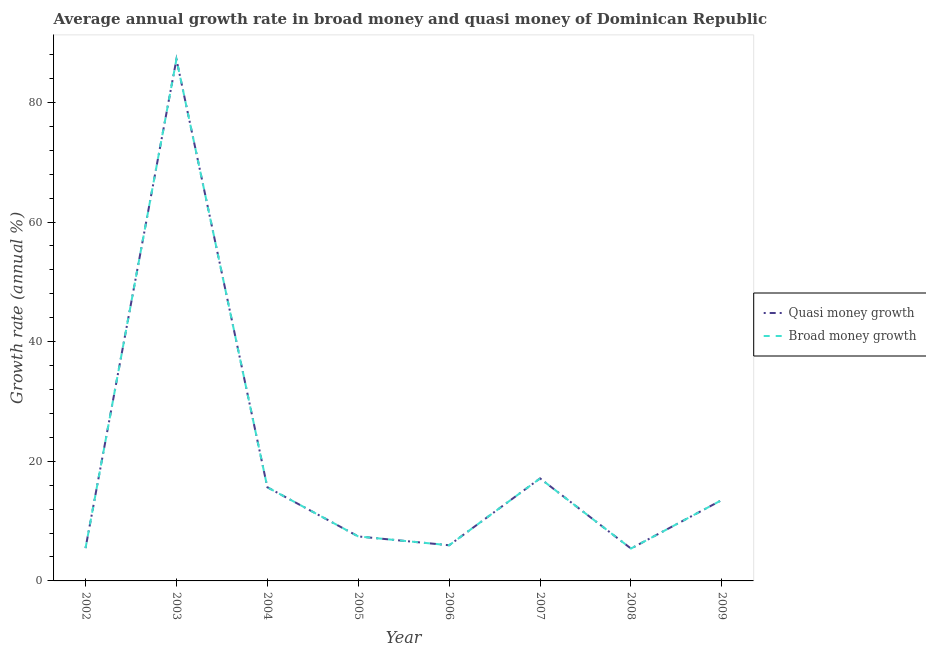How many different coloured lines are there?
Offer a very short reply. 2. Does the line corresponding to annual growth rate in broad money intersect with the line corresponding to annual growth rate in quasi money?
Give a very brief answer. Yes. Is the number of lines equal to the number of legend labels?
Provide a succinct answer. Yes. What is the annual growth rate in quasi money in 2009?
Your answer should be compact. 13.53. Across all years, what is the maximum annual growth rate in broad money?
Your response must be concise. 87.2. Across all years, what is the minimum annual growth rate in broad money?
Ensure brevity in your answer.  5.41. In which year was the annual growth rate in quasi money minimum?
Your answer should be compact. 2008. What is the total annual growth rate in quasi money in the graph?
Provide a succinct answer. 157.82. What is the difference between the annual growth rate in broad money in 2004 and that in 2009?
Offer a very short reply. 2.13. What is the difference between the annual growth rate in quasi money in 2004 and the annual growth rate in broad money in 2005?
Your answer should be compact. 8.22. What is the average annual growth rate in broad money per year?
Your answer should be very brief. 19.73. In the year 2008, what is the difference between the annual growth rate in quasi money and annual growth rate in broad money?
Provide a short and direct response. 0. What is the ratio of the annual growth rate in quasi money in 2003 to that in 2007?
Your answer should be compact. 5.09. Is the annual growth rate in quasi money in 2005 less than that in 2008?
Give a very brief answer. No. Is the difference between the annual growth rate in broad money in 2007 and 2008 greater than the difference between the annual growth rate in quasi money in 2007 and 2008?
Offer a very short reply. No. What is the difference between the highest and the second highest annual growth rate in broad money?
Your response must be concise. 70.06. What is the difference between the highest and the lowest annual growth rate in quasi money?
Keep it short and to the point. 81.79. In how many years, is the annual growth rate in quasi money greater than the average annual growth rate in quasi money taken over all years?
Offer a very short reply. 1. Does the annual growth rate in quasi money monotonically increase over the years?
Offer a terse response. No. How many lines are there?
Offer a very short reply. 2. What is the difference between two consecutive major ticks on the Y-axis?
Offer a very short reply. 20. Does the graph contain any zero values?
Provide a succinct answer. No. Does the graph contain grids?
Your response must be concise. No. Where does the legend appear in the graph?
Your answer should be compact. Center right. How many legend labels are there?
Give a very brief answer. 2. How are the legend labels stacked?
Your answer should be very brief. Vertical. What is the title of the graph?
Give a very brief answer. Average annual growth rate in broad money and quasi money of Dominican Republic. Does "Depositors" appear as one of the legend labels in the graph?
Your response must be concise. No. What is the label or title of the X-axis?
Make the answer very short. Year. What is the label or title of the Y-axis?
Your answer should be very brief. Growth rate (annual %). What is the Growth rate (annual %) in Quasi money growth in 2002?
Keep it short and to the point. 5.48. What is the Growth rate (annual %) of Broad money growth in 2002?
Offer a terse response. 5.48. What is the Growth rate (annual %) in Quasi money growth in 2003?
Your answer should be compact. 87.2. What is the Growth rate (annual %) in Broad money growth in 2003?
Provide a succinct answer. 87.2. What is the Growth rate (annual %) in Quasi money growth in 2004?
Offer a very short reply. 15.66. What is the Growth rate (annual %) of Broad money growth in 2004?
Your answer should be compact. 15.66. What is the Growth rate (annual %) in Quasi money growth in 2005?
Keep it short and to the point. 7.44. What is the Growth rate (annual %) of Broad money growth in 2005?
Your answer should be very brief. 7.44. What is the Growth rate (annual %) of Quasi money growth in 2006?
Provide a succinct answer. 5.96. What is the Growth rate (annual %) in Broad money growth in 2006?
Provide a short and direct response. 5.96. What is the Growth rate (annual %) in Quasi money growth in 2007?
Your answer should be very brief. 17.14. What is the Growth rate (annual %) of Broad money growth in 2007?
Your answer should be compact. 17.14. What is the Growth rate (annual %) of Quasi money growth in 2008?
Your answer should be very brief. 5.41. What is the Growth rate (annual %) in Broad money growth in 2008?
Keep it short and to the point. 5.41. What is the Growth rate (annual %) in Quasi money growth in 2009?
Provide a succinct answer. 13.53. What is the Growth rate (annual %) of Broad money growth in 2009?
Your answer should be compact. 13.53. Across all years, what is the maximum Growth rate (annual %) in Quasi money growth?
Make the answer very short. 87.2. Across all years, what is the maximum Growth rate (annual %) of Broad money growth?
Provide a succinct answer. 87.2. Across all years, what is the minimum Growth rate (annual %) of Quasi money growth?
Make the answer very short. 5.41. Across all years, what is the minimum Growth rate (annual %) of Broad money growth?
Keep it short and to the point. 5.41. What is the total Growth rate (annual %) in Quasi money growth in the graph?
Offer a very short reply. 157.82. What is the total Growth rate (annual %) of Broad money growth in the graph?
Keep it short and to the point. 157.82. What is the difference between the Growth rate (annual %) of Quasi money growth in 2002 and that in 2003?
Make the answer very short. -81.71. What is the difference between the Growth rate (annual %) of Broad money growth in 2002 and that in 2003?
Provide a succinct answer. -81.71. What is the difference between the Growth rate (annual %) of Quasi money growth in 2002 and that in 2004?
Make the answer very short. -10.17. What is the difference between the Growth rate (annual %) in Broad money growth in 2002 and that in 2004?
Ensure brevity in your answer.  -10.17. What is the difference between the Growth rate (annual %) in Quasi money growth in 2002 and that in 2005?
Give a very brief answer. -1.95. What is the difference between the Growth rate (annual %) in Broad money growth in 2002 and that in 2005?
Offer a terse response. -1.95. What is the difference between the Growth rate (annual %) in Quasi money growth in 2002 and that in 2006?
Keep it short and to the point. -0.48. What is the difference between the Growth rate (annual %) of Broad money growth in 2002 and that in 2006?
Offer a terse response. -0.48. What is the difference between the Growth rate (annual %) of Quasi money growth in 2002 and that in 2007?
Ensure brevity in your answer.  -11.65. What is the difference between the Growth rate (annual %) in Broad money growth in 2002 and that in 2007?
Keep it short and to the point. -11.65. What is the difference between the Growth rate (annual %) in Quasi money growth in 2002 and that in 2008?
Offer a very short reply. 0.07. What is the difference between the Growth rate (annual %) of Broad money growth in 2002 and that in 2008?
Give a very brief answer. 0.07. What is the difference between the Growth rate (annual %) of Quasi money growth in 2002 and that in 2009?
Provide a short and direct response. -8.05. What is the difference between the Growth rate (annual %) of Broad money growth in 2002 and that in 2009?
Make the answer very short. -8.05. What is the difference between the Growth rate (annual %) in Quasi money growth in 2003 and that in 2004?
Give a very brief answer. 71.54. What is the difference between the Growth rate (annual %) in Broad money growth in 2003 and that in 2004?
Give a very brief answer. 71.54. What is the difference between the Growth rate (annual %) of Quasi money growth in 2003 and that in 2005?
Offer a terse response. 79.76. What is the difference between the Growth rate (annual %) of Broad money growth in 2003 and that in 2005?
Make the answer very short. 79.76. What is the difference between the Growth rate (annual %) in Quasi money growth in 2003 and that in 2006?
Make the answer very short. 81.24. What is the difference between the Growth rate (annual %) of Broad money growth in 2003 and that in 2006?
Offer a very short reply. 81.24. What is the difference between the Growth rate (annual %) of Quasi money growth in 2003 and that in 2007?
Your response must be concise. 70.06. What is the difference between the Growth rate (annual %) of Broad money growth in 2003 and that in 2007?
Make the answer very short. 70.06. What is the difference between the Growth rate (annual %) in Quasi money growth in 2003 and that in 2008?
Offer a terse response. 81.79. What is the difference between the Growth rate (annual %) of Broad money growth in 2003 and that in 2008?
Give a very brief answer. 81.79. What is the difference between the Growth rate (annual %) in Quasi money growth in 2003 and that in 2009?
Your answer should be compact. 73.67. What is the difference between the Growth rate (annual %) in Broad money growth in 2003 and that in 2009?
Offer a terse response. 73.67. What is the difference between the Growth rate (annual %) in Quasi money growth in 2004 and that in 2005?
Your answer should be compact. 8.22. What is the difference between the Growth rate (annual %) of Broad money growth in 2004 and that in 2005?
Provide a short and direct response. 8.22. What is the difference between the Growth rate (annual %) of Quasi money growth in 2004 and that in 2006?
Your response must be concise. 9.69. What is the difference between the Growth rate (annual %) in Broad money growth in 2004 and that in 2006?
Provide a succinct answer. 9.69. What is the difference between the Growth rate (annual %) of Quasi money growth in 2004 and that in 2007?
Offer a very short reply. -1.48. What is the difference between the Growth rate (annual %) in Broad money growth in 2004 and that in 2007?
Keep it short and to the point. -1.48. What is the difference between the Growth rate (annual %) in Quasi money growth in 2004 and that in 2008?
Offer a terse response. 10.24. What is the difference between the Growth rate (annual %) in Broad money growth in 2004 and that in 2008?
Make the answer very short. 10.24. What is the difference between the Growth rate (annual %) in Quasi money growth in 2004 and that in 2009?
Keep it short and to the point. 2.12. What is the difference between the Growth rate (annual %) in Broad money growth in 2004 and that in 2009?
Provide a short and direct response. 2.12. What is the difference between the Growth rate (annual %) in Quasi money growth in 2005 and that in 2006?
Keep it short and to the point. 1.48. What is the difference between the Growth rate (annual %) of Broad money growth in 2005 and that in 2006?
Your answer should be compact. 1.48. What is the difference between the Growth rate (annual %) in Quasi money growth in 2005 and that in 2007?
Give a very brief answer. -9.7. What is the difference between the Growth rate (annual %) of Broad money growth in 2005 and that in 2007?
Provide a succinct answer. -9.7. What is the difference between the Growth rate (annual %) of Quasi money growth in 2005 and that in 2008?
Your answer should be very brief. 2.03. What is the difference between the Growth rate (annual %) of Broad money growth in 2005 and that in 2008?
Provide a succinct answer. 2.03. What is the difference between the Growth rate (annual %) of Quasi money growth in 2005 and that in 2009?
Keep it short and to the point. -6.09. What is the difference between the Growth rate (annual %) in Broad money growth in 2005 and that in 2009?
Your response must be concise. -6.09. What is the difference between the Growth rate (annual %) in Quasi money growth in 2006 and that in 2007?
Ensure brevity in your answer.  -11.17. What is the difference between the Growth rate (annual %) in Broad money growth in 2006 and that in 2007?
Your response must be concise. -11.17. What is the difference between the Growth rate (annual %) in Quasi money growth in 2006 and that in 2008?
Give a very brief answer. 0.55. What is the difference between the Growth rate (annual %) of Broad money growth in 2006 and that in 2008?
Your answer should be compact. 0.55. What is the difference between the Growth rate (annual %) in Quasi money growth in 2006 and that in 2009?
Provide a succinct answer. -7.57. What is the difference between the Growth rate (annual %) of Broad money growth in 2006 and that in 2009?
Provide a short and direct response. -7.57. What is the difference between the Growth rate (annual %) of Quasi money growth in 2007 and that in 2008?
Offer a terse response. 11.72. What is the difference between the Growth rate (annual %) of Broad money growth in 2007 and that in 2008?
Offer a very short reply. 11.72. What is the difference between the Growth rate (annual %) of Quasi money growth in 2007 and that in 2009?
Offer a very short reply. 3.61. What is the difference between the Growth rate (annual %) of Broad money growth in 2007 and that in 2009?
Your answer should be very brief. 3.61. What is the difference between the Growth rate (annual %) of Quasi money growth in 2008 and that in 2009?
Ensure brevity in your answer.  -8.12. What is the difference between the Growth rate (annual %) of Broad money growth in 2008 and that in 2009?
Offer a terse response. -8.12. What is the difference between the Growth rate (annual %) in Quasi money growth in 2002 and the Growth rate (annual %) in Broad money growth in 2003?
Give a very brief answer. -81.71. What is the difference between the Growth rate (annual %) in Quasi money growth in 2002 and the Growth rate (annual %) in Broad money growth in 2004?
Provide a short and direct response. -10.17. What is the difference between the Growth rate (annual %) in Quasi money growth in 2002 and the Growth rate (annual %) in Broad money growth in 2005?
Provide a short and direct response. -1.95. What is the difference between the Growth rate (annual %) of Quasi money growth in 2002 and the Growth rate (annual %) of Broad money growth in 2006?
Provide a short and direct response. -0.48. What is the difference between the Growth rate (annual %) in Quasi money growth in 2002 and the Growth rate (annual %) in Broad money growth in 2007?
Keep it short and to the point. -11.65. What is the difference between the Growth rate (annual %) of Quasi money growth in 2002 and the Growth rate (annual %) of Broad money growth in 2008?
Your answer should be very brief. 0.07. What is the difference between the Growth rate (annual %) of Quasi money growth in 2002 and the Growth rate (annual %) of Broad money growth in 2009?
Keep it short and to the point. -8.05. What is the difference between the Growth rate (annual %) in Quasi money growth in 2003 and the Growth rate (annual %) in Broad money growth in 2004?
Offer a terse response. 71.54. What is the difference between the Growth rate (annual %) of Quasi money growth in 2003 and the Growth rate (annual %) of Broad money growth in 2005?
Provide a short and direct response. 79.76. What is the difference between the Growth rate (annual %) in Quasi money growth in 2003 and the Growth rate (annual %) in Broad money growth in 2006?
Offer a terse response. 81.24. What is the difference between the Growth rate (annual %) of Quasi money growth in 2003 and the Growth rate (annual %) of Broad money growth in 2007?
Your response must be concise. 70.06. What is the difference between the Growth rate (annual %) in Quasi money growth in 2003 and the Growth rate (annual %) in Broad money growth in 2008?
Ensure brevity in your answer.  81.79. What is the difference between the Growth rate (annual %) in Quasi money growth in 2003 and the Growth rate (annual %) in Broad money growth in 2009?
Give a very brief answer. 73.67. What is the difference between the Growth rate (annual %) in Quasi money growth in 2004 and the Growth rate (annual %) in Broad money growth in 2005?
Give a very brief answer. 8.22. What is the difference between the Growth rate (annual %) in Quasi money growth in 2004 and the Growth rate (annual %) in Broad money growth in 2006?
Offer a very short reply. 9.69. What is the difference between the Growth rate (annual %) of Quasi money growth in 2004 and the Growth rate (annual %) of Broad money growth in 2007?
Ensure brevity in your answer.  -1.48. What is the difference between the Growth rate (annual %) in Quasi money growth in 2004 and the Growth rate (annual %) in Broad money growth in 2008?
Your answer should be compact. 10.24. What is the difference between the Growth rate (annual %) of Quasi money growth in 2004 and the Growth rate (annual %) of Broad money growth in 2009?
Your answer should be compact. 2.12. What is the difference between the Growth rate (annual %) of Quasi money growth in 2005 and the Growth rate (annual %) of Broad money growth in 2006?
Make the answer very short. 1.48. What is the difference between the Growth rate (annual %) of Quasi money growth in 2005 and the Growth rate (annual %) of Broad money growth in 2007?
Give a very brief answer. -9.7. What is the difference between the Growth rate (annual %) of Quasi money growth in 2005 and the Growth rate (annual %) of Broad money growth in 2008?
Offer a very short reply. 2.03. What is the difference between the Growth rate (annual %) in Quasi money growth in 2005 and the Growth rate (annual %) in Broad money growth in 2009?
Your answer should be compact. -6.09. What is the difference between the Growth rate (annual %) of Quasi money growth in 2006 and the Growth rate (annual %) of Broad money growth in 2007?
Make the answer very short. -11.17. What is the difference between the Growth rate (annual %) in Quasi money growth in 2006 and the Growth rate (annual %) in Broad money growth in 2008?
Give a very brief answer. 0.55. What is the difference between the Growth rate (annual %) in Quasi money growth in 2006 and the Growth rate (annual %) in Broad money growth in 2009?
Your answer should be very brief. -7.57. What is the difference between the Growth rate (annual %) of Quasi money growth in 2007 and the Growth rate (annual %) of Broad money growth in 2008?
Your response must be concise. 11.72. What is the difference between the Growth rate (annual %) in Quasi money growth in 2007 and the Growth rate (annual %) in Broad money growth in 2009?
Your answer should be very brief. 3.61. What is the difference between the Growth rate (annual %) of Quasi money growth in 2008 and the Growth rate (annual %) of Broad money growth in 2009?
Offer a very short reply. -8.12. What is the average Growth rate (annual %) in Quasi money growth per year?
Make the answer very short. 19.73. What is the average Growth rate (annual %) in Broad money growth per year?
Ensure brevity in your answer.  19.73. In the year 2002, what is the difference between the Growth rate (annual %) in Quasi money growth and Growth rate (annual %) in Broad money growth?
Ensure brevity in your answer.  0. In the year 2003, what is the difference between the Growth rate (annual %) in Quasi money growth and Growth rate (annual %) in Broad money growth?
Keep it short and to the point. 0. In the year 2005, what is the difference between the Growth rate (annual %) of Quasi money growth and Growth rate (annual %) of Broad money growth?
Keep it short and to the point. 0. In the year 2006, what is the difference between the Growth rate (annual %) of Quasi money growth and Growth rate (annual %) of Broad money growth?
Your answer should be very brief. 0. In the year 2007, what is the difference between the Growth rate (annual %) of Quasi money growth and Growth rate (annual %) of Broad money growth?
Offer a terse response. 0. In the year 2009, what is the difference between the Growth rate (annual %) in Quasi money growth and Growth rate (annual %) in Broad money growth?
Your answer should be very brief. 0. What is the ratio of the Growth rate (annual %) of Quasi money growth in 2002 to that in 2003?
Your response must be concise. 0.06. What is the ratio of the Growth rate (annual %) of Broad money growth in 2002 to that in 2003?
Your answer should be very brief. 0.06. What is the ratio of the Growth rate (annual %) in Quasi money growth in 2002 to that in 2004?
Keep it short and to the point. 0.35. What is the ratio of the Growth rate (annual %) in Broad money growth in 2002 to that in 2004?
Give a very brief answer. 0.35. What is the ratio of the Growth rate (annual %) in Quasi money growth in 2002 to that in 2005?
Your answer should be compact. 0.74. What is the ratio of the Growth rate (annual %) of Broad money growth in 2002 to that in 2005?
Make the answer very short. 0.74. What is the ratio of the Growth rate (annual %) of Quasi money growth in 2002 to that in 2006?
Offer a very short reply. 0.92. What is the ratio of the Growth rate (annual %) of Broad money growth in 2002 to that in 2006?
Your answer should be very brief. 0.92. What is the ratio of the Growth rate (annual %) of Quasi money growth in 2002 to that in 2007?
Offer a very short reply. 0.32. What is the ratio of the Growth rate (annual %) of Broad money growth in 2002 to that in 2007?
Provide a succinct answer. 0.32. What is the ratio of the Growth rate (annual %) of Quasi money growth in 2002 to that in 2008?
Offer a terse response. 1.01. What is the ratio of the Growth rate (annual %) in Broad money growth in 2002 to that in 2008?
Your answer should be compact. 1.01. What is the ratio of the Growth rate (annual %) in Quasi money growth in 2002 to that in 2009?
Your response must be concise. 0.41. What is the ratio of the Growth rate (annual %) in Broad money growth in 2002 to that in 2009?
Offer a terse response. 0.41. What is the ratio of the Growth rate (annual %) in Quasi money growth in 2003 to that in 2004?
Your response must be concise. 5.57. What is the ratio of the Growth rate (annual %) of Broad money growth in 2003 to that in 2004?
Give a very brief answer. 5.57. What is the ratio of the Growth rate (annual %) of Quasi money growth in 2003 to that in 2005?
Offer a terse response. 11.72. What is the ratio of the Growth rate (annual %) in Broad money growth in 2003 to that in 2005?
Ensure brevity in your answer.  11.72. What is the ratio of the Growth rate (annual %) of Quasi money growth in 2003 to that in 2006?
Make the answer very short. 14.62. What is the ratio of the Growth rate (annual %) in Broad money growth in 2003 to that in 2006?
Give a very brief answer. 14.62. What is the ratio of the Growth rate (annual %) in Quasi money growth in 2003 to that in 2007?
Make the answer very short. 5.09. What is the ratio of the Growth rate (annual %) of Broad money growth in 2003 to that in 2007?
Make the answer very short. 5.09. What is the ratio of the Growth rate (annual %) in Quasi money growth in 2003 to that in 2008?
Your answer should be very brief. 16.11. What is the ratio of the Growth rate (annual %) of Broad money growth in 2003 to that in 2008?
Your answer should be compact. 16.11. What is the ratio of the Growth rate (annual %) in Quasi money growth in 2003 to that in 2009?
Offer a very short reply. 6.44. What is the ratio of the Growth rate (annual %) of Broad money growth in 2003 to that in 2009?
Provide a succinct answer. 6.44. What is the ratio of the Growth rate (annual %) in Quasi money growth in 2004 to that in 2005?
Keep it short and to the point. 2.11. What is the ratio of the Growth rate (annual %) in Broad money growth in 2004 to that in 2005?
Your answer should be very brief. 2.11. What is the ratio of the Growth rate (annual %) in Quasi money growth in 2004 to that in 2006?
Give a very brief answer. 2.63. What is the ratio of the Growth rate (annual %) in Broad money growth in 2004 to that in 2006?
Provide a succinct answer. 2.63. What is the ratio of the Growth rate (annual %) in Quasi money growth in 2004 to that in 2007?
Provide a succinct answer. 0.91. What is the ratio of the Growth rate (annual %) of Broad money growth in 2004 to that in 2007?
Offer a very short reply. 0.91. What is the ratio of the Growth rate (annual %) in Quasi money growth in 2004 to that in 2008?
Keep it short and to the point. 2.89. What is the ratio of the Growth rate (annual %) in Broad money growth in 2004 to that in 2008?
Make the answer very short. 2.89. What is the ratio of the Growth rate (annual %) in Quasi money growth in 2004 to that in 2009?
Your answer should be very brief. 1.16. What is the ratio of the Growth rate (annual %) of Broad money growth in 2004 to that in 2009?
Provide a succinct answer. 1.16. What is the ratio of the Growth rate (annual %) in Quasi money growth in 2005 to that in 2006?
Offer a very short reply. 1.25. What is the ratio of the Growth rate (annual %) in Broad money growth in 2005 to that in 2006?
Ensure brevity in your answer.  1.25. What is the ratio of the Growth rate (annual %) in Quasi money growth in 2005 to that in 2007?
Make the answer very short. 0.43. What is the ratio of the Growth rate (annual %) of Broad money growth in 2005 to that in 2007?
Provide a succinct answer. 0.43. What is the ratio of the Growth rate (annual %) of Quasi money growth in 2005 to that in 2008?
Ensure brevity in your answer.  1.37. What is the ratio of the Growth rate (annual %) of Broad money growth in 2005 to that in 2008?
Give a very brief answer. 1.37. What is the ratio of the Growth rate (annual %) in Quasi money growth in 2005 to that in 2009?
Keep it short and to the point. 0.55. What is the ratio of the Growth rate (annual %) of Broad money growth in 2005 to that in 2009?
Ensure brevity in your answer.  0.55. What is the ratio of the Growth rate (annual %) in Quasi money growth in 2006 to that in 2007?
Make the answer very short. 0.35. What is the ratio of the Growth rate (annual %) of Broad money growth in 2006 to that in 2007?
Provide a short and direct response. 0.35. What is the ratio of the Growth rate (annual %) in Quasi money growth in 2006 to that in 2008?
Your answer should be very brief. 1.1. What is the ratio of the Growth rate (annual %) of Broad money growth in 2006 to that in 2008?
Offer a terse response. 1.1. What is the ratio of the Growth rate (annual %) in Quasi money growth in 2006 to that in 2009?
Ensure brevity in your answer.  0.44. What is the ratio of the Growth rate (annual %) of Broad money growth in 2006 to that in 2009?
Your answer should be very brief. 0.44. What is the ratio of the Growth rate (annual %) of Quasi money growth in 2007 to that in 2008?
Give a very brief answer. 3.17. What is the ratio of the Growth rate (annual %) in Broad money growth in 2007 to that in 2008?
Your answer should be compact. 3.17. What is the ratio of the Growth rate (annual %) in Quasi money growth in 2007 to that in 2009?
Your answer should be compact. 1.27. What is the ratio of the Growth rate (annual %) of Broad money growth in 2007 to that in 2009?
Provide a short and direct response. 1.27. What is the difference between the highest and the second highest Growth rate (annual %) of Quasi money growth?
Ensure brevity in your answer.  70.06. What is the difference between the highest and the second highest Growth rate (annual %) of Broad money growth?
Ensure brevity in your answer.  70.06. What is the difference between the highest and the lowest Growth rate (annual %) in Quasi money growth?
Make the answer very short. 81.79. What is the difference between the highest and the lowest Growth rate (annual %) of Broad money growth?
Keep it short and to the point. 81.79. 